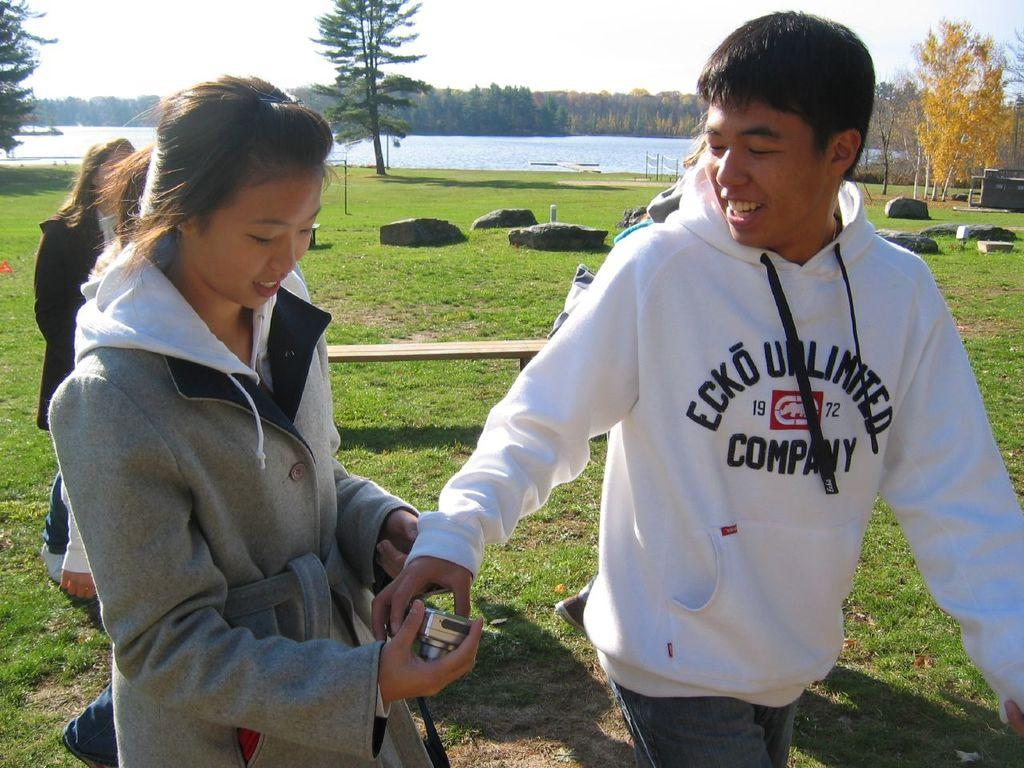<image>
Render a clear and concise summary of the photo. A man wearing an Ecko sweatshirt walks next to a woman holding a camera. 